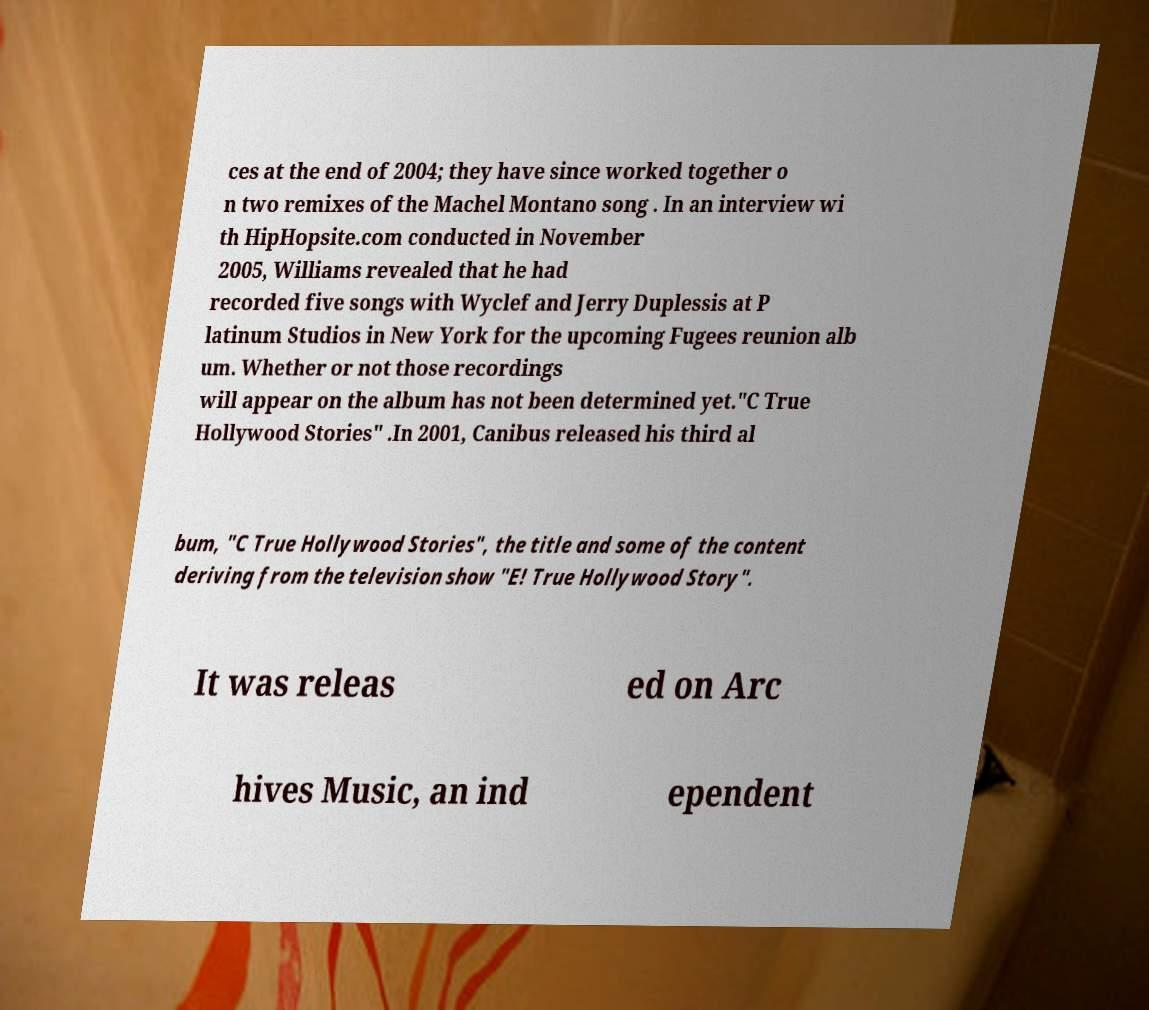Could you assist in decoding the text presented in this image and type it out clearly? ces at the end of 2004; they have since worked together o n two remixes of the Machel Montano song . In an interview wi th HipHopsite.com conducted in November 2005, Williams revealed that he had recorded five songs with Wyclef and Jerry Duplessis at P latinum Studios in New York for the upcoming Fugees reunion alb um. Whether or not those recordings will appear on the album has not been determined yet."C True Hollywood Stories" .In 2001, Canibus released his third al bum, "C True Hollywood Stories", the title and some of the content deriving from the television show "E! True Hollywood Story". It was releas ed on Arc hives Music, an ind ependent 